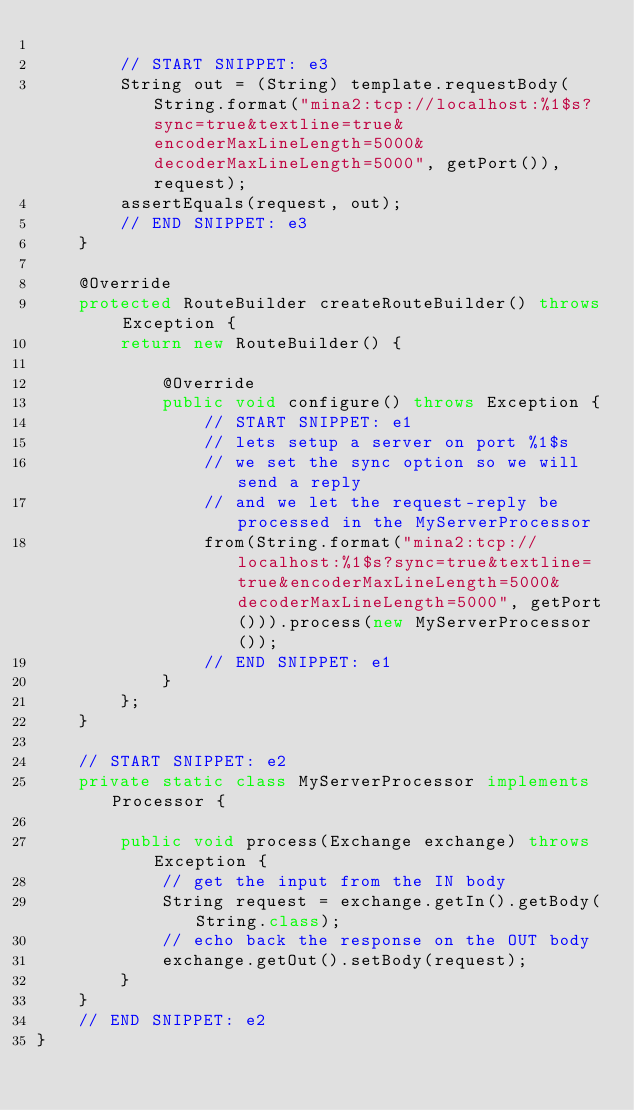Convert code to text. <code><loc_0><loc_0><loc_500><loc_500><_Java_>
        // START SNIPPET: e3
        String out = (String) template.requestBody(String.format("mina2:tcp://localhost:%1$s?sync=true&textline=true&encoderMaxLineLength=5000&decoderMaxLineLength=5000", getPort()), request);
        assertEquals(request, out);
        // END SNIPPET: e3
    }

    @Override
    protected RouteBuilder createRouteBuilder() throws Exception {
        return new RouteBuilder() {

            @Override
            public void configure() throws Exception {
                // START SNIPPET: e1
                // lets setup a server on port %1$s
                // we set the sync option so we will send a reply
                // and we let the request-reply be processed in the MyServerProcessor
                from(String.format("mina2:tcp://localhost:%1$s?sync=true&textline=true&encoderMaxLineLength=5000&decoderMaxLineLength=5000", getPort())).process(new MyServerProcessor());
                // END SNIPPET: e1
            }
        };
    }

    // START SNIPPET: e2
    private static class MyServerProcessor implements Processor {

        public void process(Exchange exchange) throws Exception {
            // get the input from the IN body
            String request = exchange.getIn().getBody(String.class);
            // echo back the response on the OUT body
            exchange.getOut().setBody(request);
        }
    }
    // END SNIPPET: e2
}
</code> 